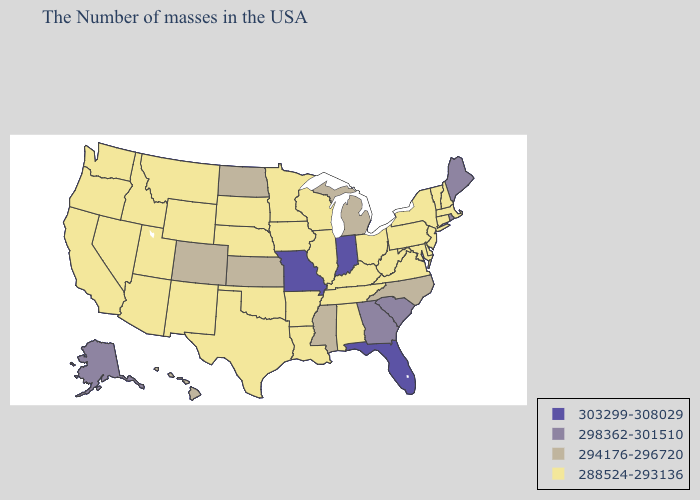Does Hawaii have the same value as New Mexico?
Keep it brief. No. Does the map have missing data?
Write a very short answer. No. What is the value of Florida?
Quick response, please. 303299-308029. Does Alabama have the same value as Louisiana?
Short answer required. Yes. What is the highest value in states that border Nebraska?
Short answer required. 303299-308029. Name the states that have a value in the range 288524-293136?
Answer briefly. Massachusetts, New Hampshire, Vermont, Connecticut, New York, New Jersey, Delaware, Maryland, Pennsylvania, Virginia, West Virginia, Ohio, Kentucky, Alabama, Tennessee, Wisconsin, Illinois, Louisiana, Arkansas, Minnesota, Iowa, Nebraska, Oklahoma, Texas, South Dakota, Wyoming, New Mexico, Utah, Montana, Arizona, Idaho, Nevada, California, Washington, Oregon. Name the states that have a value in the range 298362-301510?
Short answer required. Maine, Rhode Island, South Carolina, Georgia, Alaska. Name the states that have a value in the range 303299-308029?
Be succinct. Florida, Indiana, Missouri. Is the legend a continuous bar?
Answer briefly. No. What is the value of Arkansas?
Write a very short answer. 288524-293136. Does the map have missing data?
Short answer required. No. Does the map have missing data?
Short answer required. No. How many symbols are there in the legend?
Write a very short answer. 4. Which states hav the highest value in the MidWest?
Write a very short answer. Indiana, Missouri. Does Florida have the highest value in the South?
Keep it brief. Yes. 